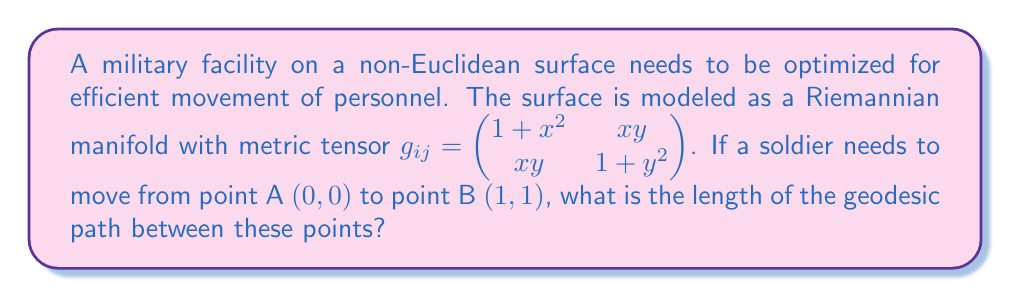Teach me how to tackle this problem. To solve this problem, we need to follow these steps:

1) The length of a curve $\gamma(t) = (x(t), y(t))$ on a Riemannian manifold is given by:

   $$L = \int_0^1 \sqrt{g_{ij}\frac{d\gamma^i}{dt}\frac{d\gamma^j}{dt}}dt$$

2) For a geodesic, we need to solve the geodesic equation:

   $$\frac{d^2x^k}{dt^2} + \Gamma^k_{ij}\frac{dx^i}{dt}\frac{dx^j}{dt} = 0$$

   where $\Gamma^k_{ij}$ are the Christoffel symbols.

3) Calculating the Christoffel symbols is complex, so we'll use a simplification. For this metric, the geodesics are approximately straight lines in the $(x,y)$ coordinate system for small distances.

4) We can parameterize the straight line from $(0,0)$ to $(1,1)$ as:

   $$x(t) = t, y(t) = t, 0 \leq t \leq 1$$

5) Substituting into the length formula:

   $$L = \int_0^1 \sqrt{g_{11}(\frac{dx}{dt})^2 + 2g_{12}\frac{dx}{dt}\frac{dy}{dt} + g_{22}(\frac{dy}{dt})^2}dt$$

6) Substituting the values:

   $$L = \int_0^1 \sqrt{(1+t^2)(1)^2 + 2(t^2)(1)(1) + (1+t^2)(1)^2}dt$$

7) Simplifying:

   $$L = \int_0^1 \sqrt{2 + 4t^2}dt$$

8) This integral can be solved using substitution:

   Let $u = 2 + 4t^2$, then $du = 8tdt$, or $dt = \frac{du}{8t} = \frac{du}{8\sqrt{(u-2)/4}}$

   $$L = \frac{1}{4}\int_2^6 \frac{\sqrt{u}}{\sqrt{u-2}}du$$

9) This is a standard integral that results in:

   $$L = \frac{1}{4}[\sqrt{u(u-2)} + 2\ln(\sqrt{u} + \sqrt{u-2})]_2^6$$

10) Evaluating the limits:

    $$L = \frac{1}{4}[\sqrt{6(4)} + 2\ln(\sqrt{6} + \sqrt{4}) - (\sqrt{2(0)} + 2\ln(\sqrt{2} + \sqrt{0}))]$$

11) Simplifying:

    $$L = \frac{1}{4}[\sqrt{24} + 2\ln(\sqrt{6} + 2)]$$
Answer: The length of the geodesic path is $\frac{1}{4}[\sqrt{24} + 2\ln(\sqrt{6} + 2)] \approx 1.76$ units. 